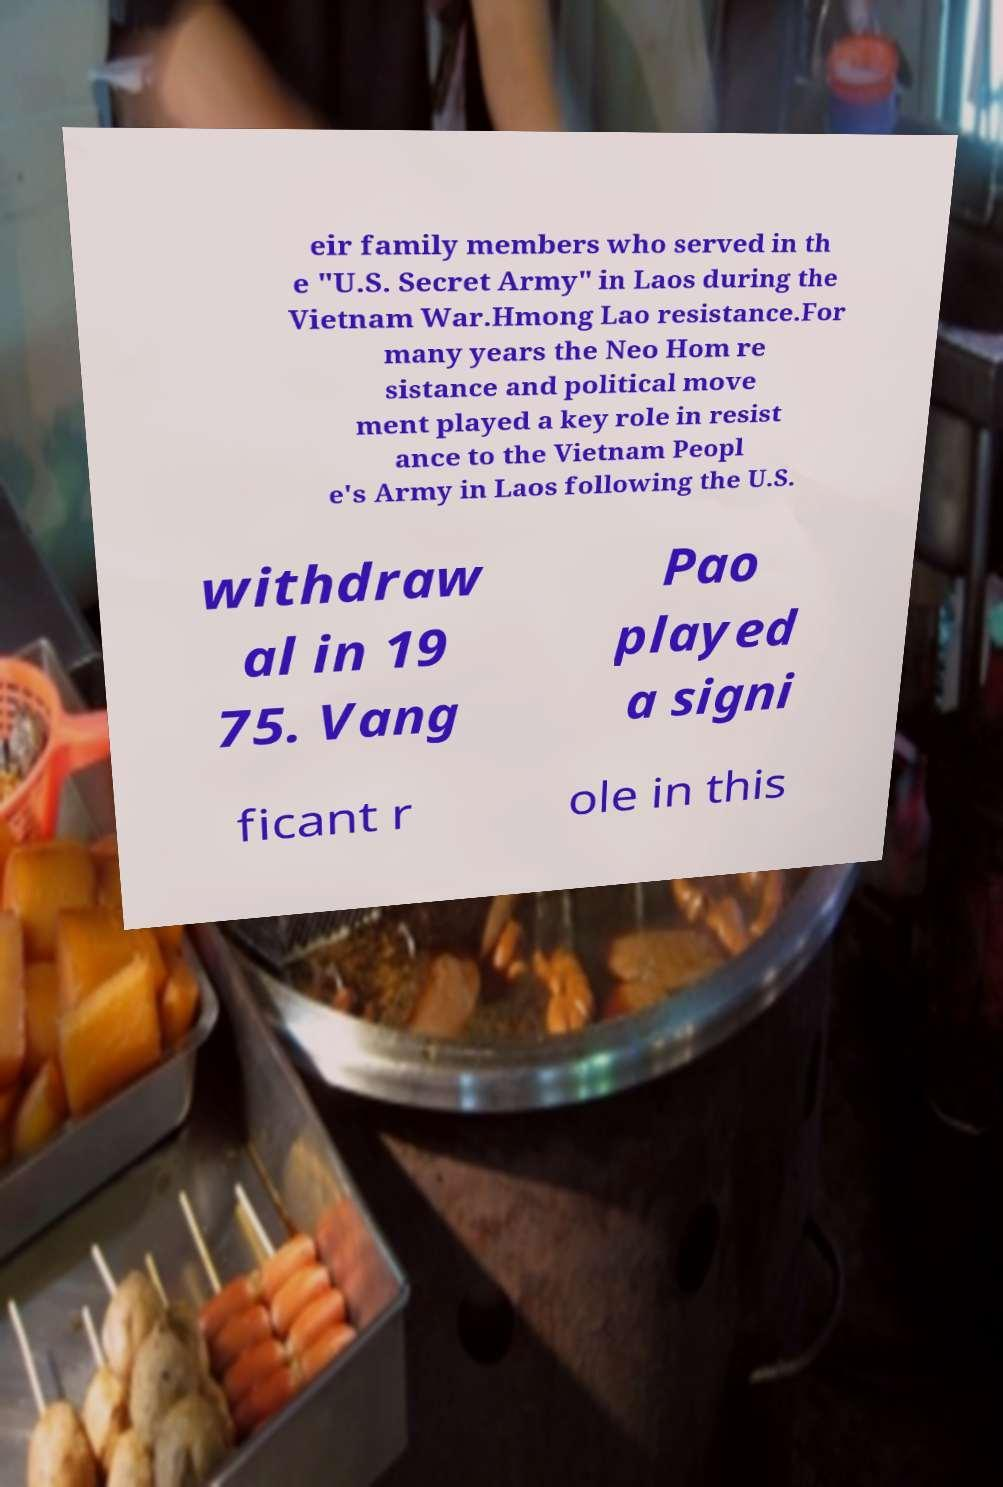Could you extract and type out the text from this image? eir family members who served in th e "U.S. Secret Army" in Laos during the Vietnam War.Hmong Lao resistance.For many years the Neo Hom re sistance and political move ment played a key role in resist ance to the Vietnam Peopl e's Army in Laos following the U.S. withdraw al in 19 75. Vang Pao played a signi ficant r ole in this 